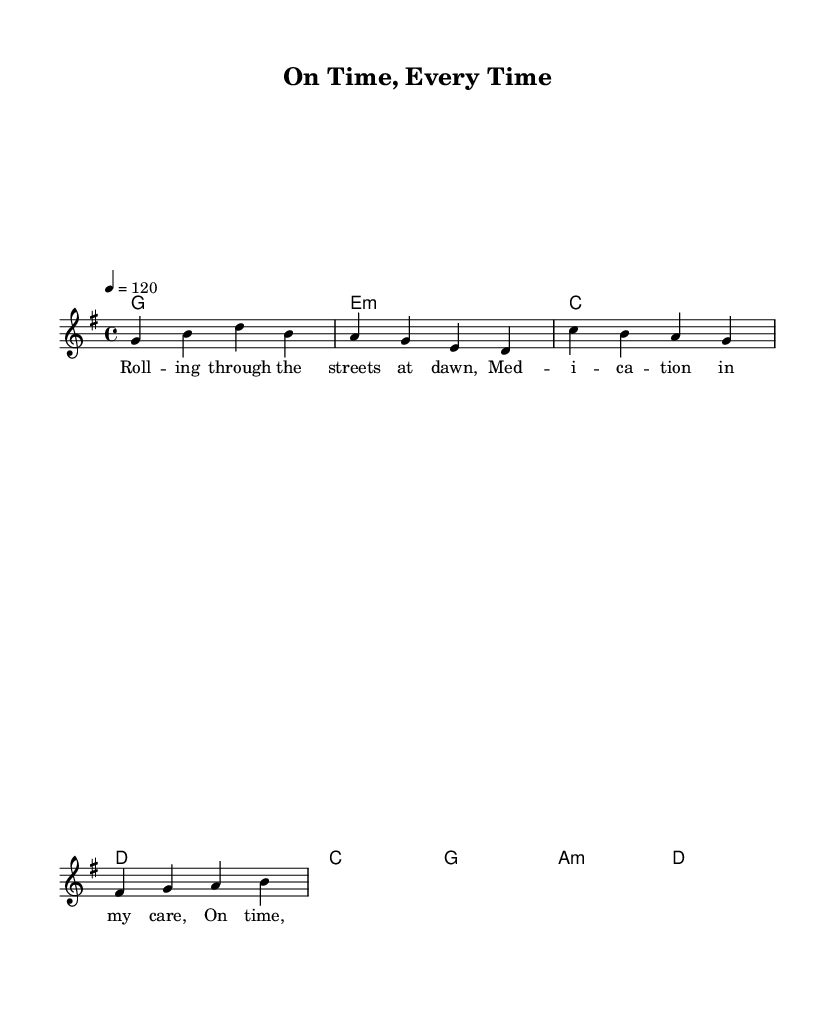What is the key signature of this music? The key signature is G major, which has one sharp (F#). It can be identified at the beginning of the staff.
Answer: G major What is the time signature of this music? The time signature is 4/4, indicating four beats in a measure and a quarter note receives one beat. It is shown at the beginning of the piece next to the key signature.
Answer: 4/4 What is the tempo marking for this piece? The tempo marking is quarter note equals 120, which indicates the speed of the music. This can be found in the tempo indication, typically placed above the staff.
Answer: 120 How many measures are there in the verse? The verse contains four measures, which can be counted by looking at the slashes in between the notes or the number of vertical lines dividing the music.
Answer: 4 What are the chords used in the chorus? The chords used in the chorus are C, G, A minor, and D. This information is placed in the chord section alongside the melody and can be read directly from the notation.
Answer: C, G, A minor, D What is the lyrical theme of the song? The lyrical theme focuses on responsibility and commitment, evident from the lyrics emphasizing punctuality in delivering medication.
Answer: Responsibility What musical genre does this piece belong to? The piece belongs to indie rock, as indicated by its style, structure, and themes presented in the lyrics and music.
Answer: Indie rock 